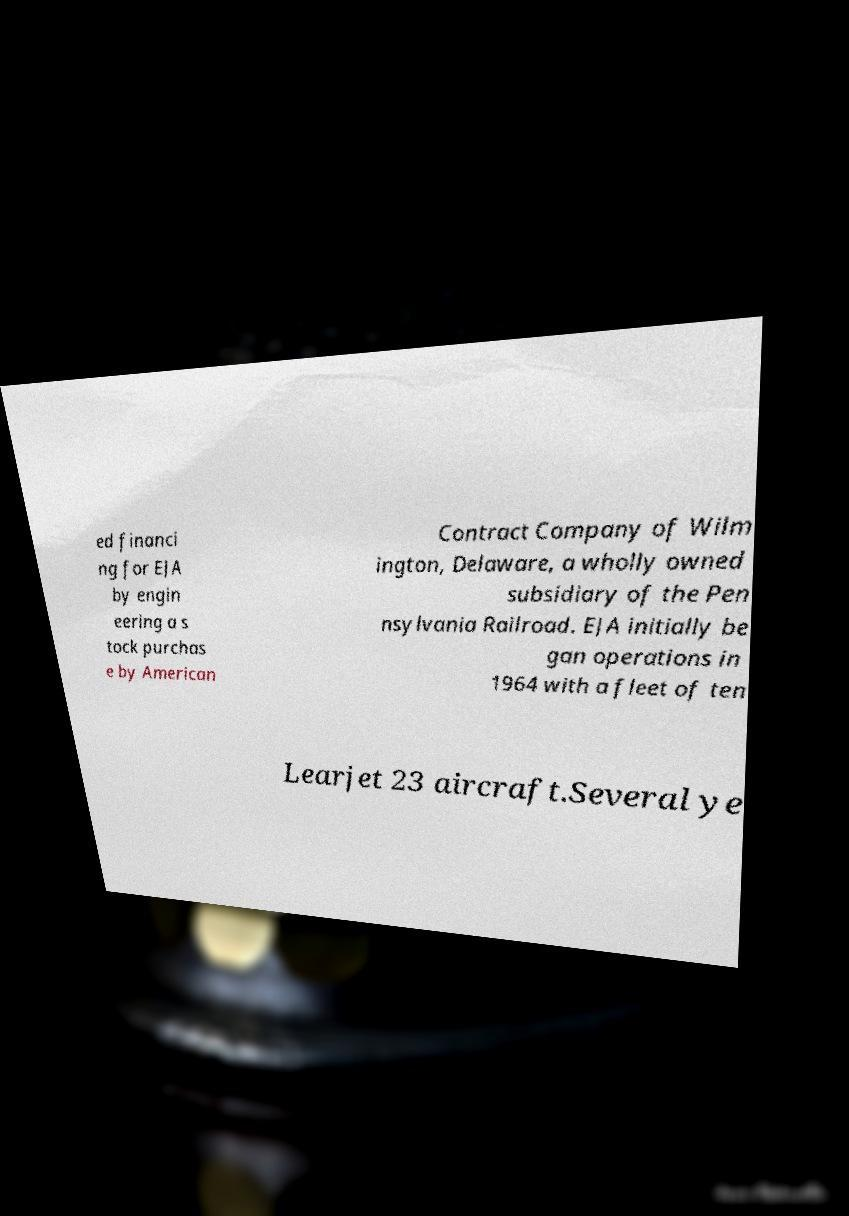I need the written content from this picture converted into text. Can you do that? ed financi ng for EJA by engin eering a s tock purchas e by American Contract Company of Wilm ington, Delaware, a wholly owned subsidiary of the Pen nsylvania Railroad. EJA initially be gan operations in 1964 with a fleet of ten Learjet 23 aircraft.Several ye 